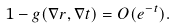<formula> <loc_0><loc_0><loc_500><loc_500>1 - g ( \nabla r , \nabla t ) = O ( e ^ { - t } ) .</formula> 